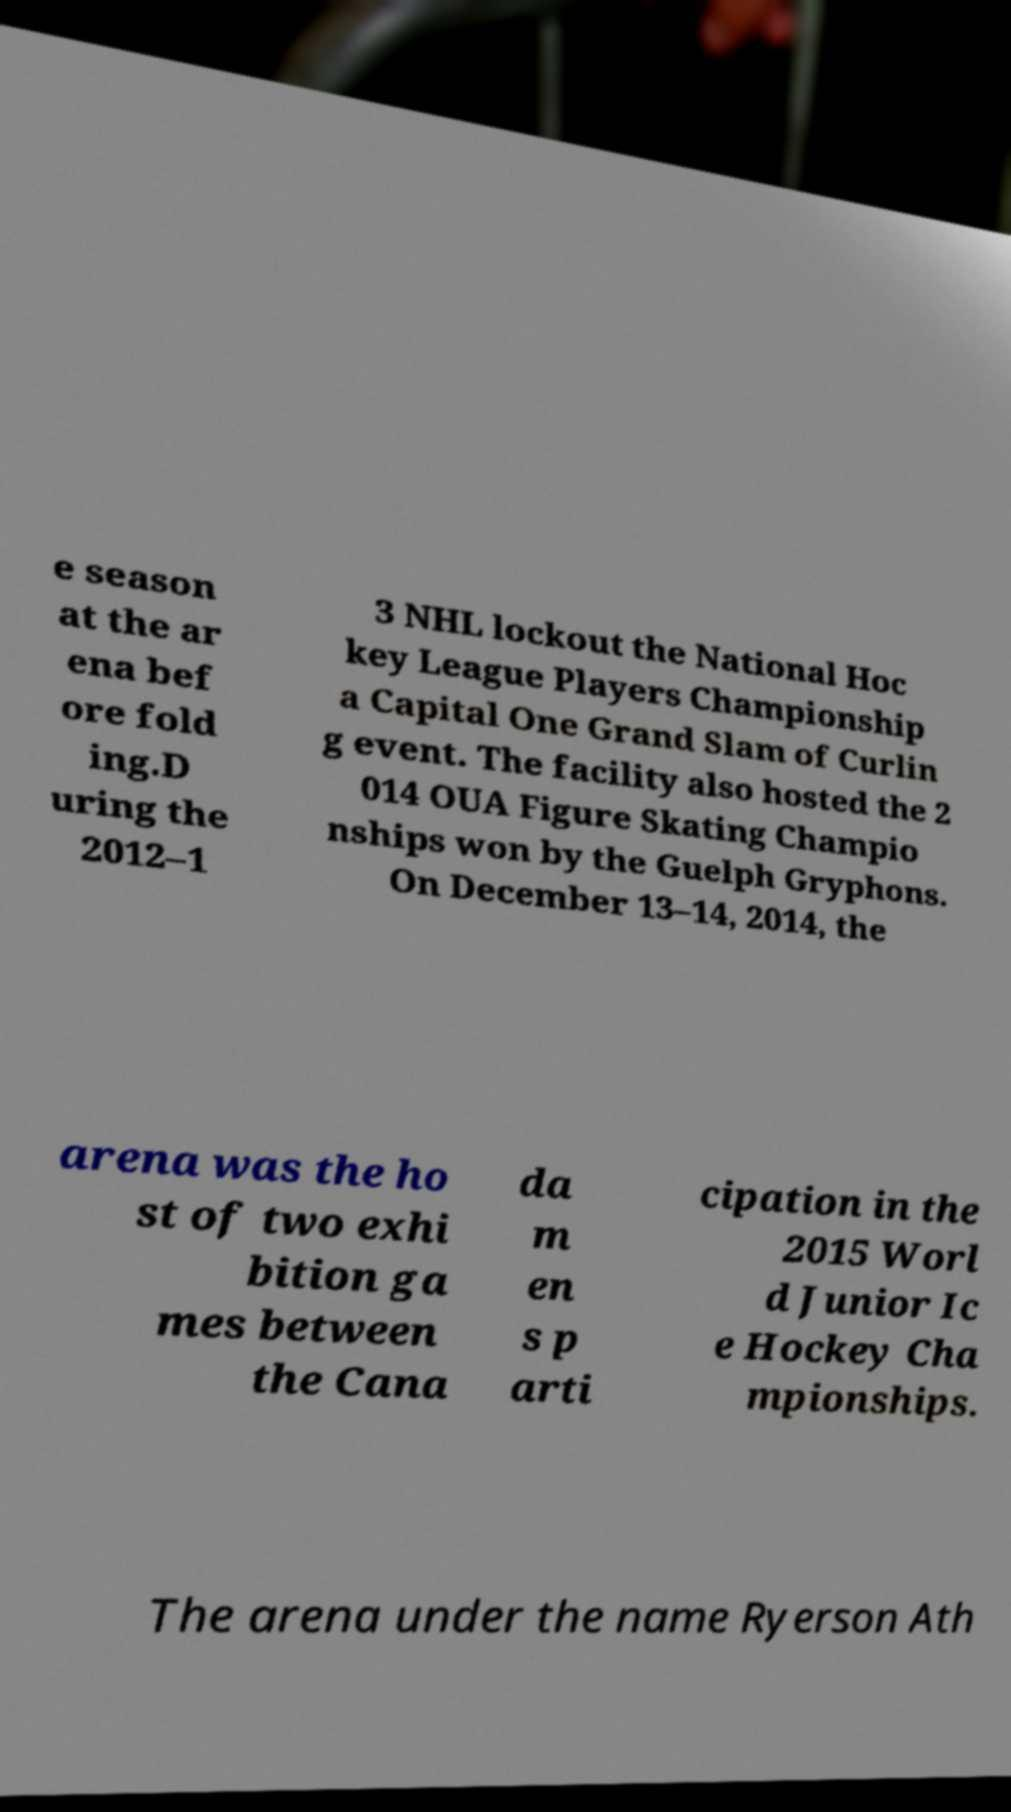What messages or text are displayed in this image? I need them in a readable, typed format. e season at the ar ena bef ore fold ing.D uring the 2012–1 3 NHL lockout the National Hoc key League Players Championship a Capital One Grand Slam of Curlin g event. The facility also hosted the 2 014 OUA Figure Skating Champio nships won by the Guelph Gryphons. On December 13–14, 2014, the arena was the ho st of two exhi bition ga mes between the Cana da m en s p arti cipation in the 2015 Worl d Junior Ic e Hockey Cha mpionships. The arena under the name Ryerson Ath 